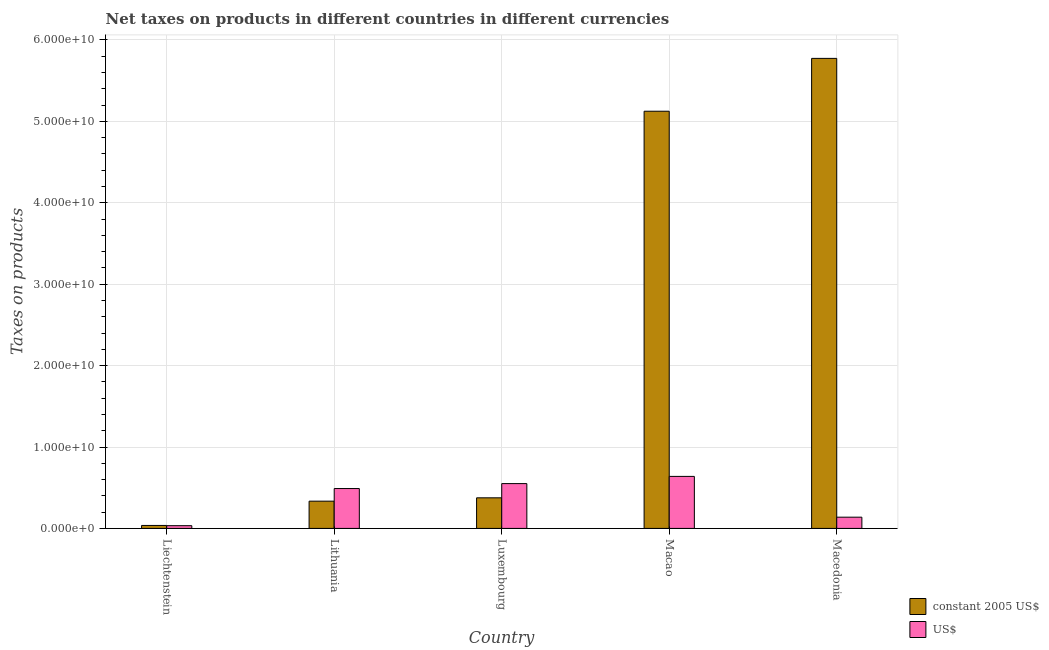Are the number of bars per tick equal to the number of legend labels?
Provide a short and direct response. Yes. Are the number of bars on each tick of the X-axis equal?
Make the answer very short. Yes. How many bars are there on the 5th tick from the left?
Your answer should be compact. 2. What is the label of the 1st group of bars from the left?
Keep it short and to the point. Liechtenstein. What is the net taxes in constant 2005 us$ in Liechtenstein?
Offer a terse response. 3.64e+08. Across all countries, what is the maximum net taxes in us$?
Ensure brevity in your answer.  6.39e+09. Across all countries, what is the minimum net taxes in us$?
Your answer should be very brief. 3.36e+08. In which country was the net taxes in constant 2005 us$ maximum?
Make the answer very short. Macedonia. In which country was the net taxes in us$ minimum?
Offer a terse response. Liechtenstein. What is the total net taxes in us$ in the graph?
Your answer should be very brief. 1.85e+1. What is the difference between the net taxes in constant 2005 us$ in Macao and that in Macedonia?
Give a very brief answer. -6.49e+09. What is the difference between the net taxes in us$ in Luxembourg and the net taxes in constant 2005 us$ in Liechtenstein?
Your answer should be compact. 5.14e+09. What is the average net taxes in constant 2005 us$ per country?
Make the answer very short. 2.33e+1. What is the difference between the net taxes in constant 2005 us$ and net taxes in us$ in Macao?
Give a very brief answer. 4.49e+1. In how many countries, is the net taxes in us$ greater than 24000000000 units?
Give a very brief answer. 0. What is the ratio of the net taxes in us$ in Macao to that in Macedonia?
Give a very brief answer. 4.63. Is the net taxes in us$ in Lithuania less than that in Luxembourg?
Your answer should be very brief. Yes. Is the difference between the net taxes in us$ in Liechtenstein and Macedonia greater than the difference between the net taxes in constant 2005 us$ in Liechtenstein and Macedonia?
Offer a terse response. Yes. What is the difference between the highest and the second highest net taxes in us$?
Your answer should be compact. 8.85e+08. What is the difference between the highest and the lowest net taxes in constant 2005 us$?
Your response must be concise. 5.74e+1. What does the 2nd bar from the left in Macao represents?
Your answer should be very brief. US$. What does the 1st bar from the right in Luxembourg represents?
Give a very brief answer. US$. How many countries are there in the graph?
Offer a very short reply. 5. Does the graph contain grids?
Your response must be concise. Yes. How are the legend labels stacked?
Give a very brief answer. Vertical. What is the title of the graph?
Your answer should be compact. Net taxes on products in different countries in different currencies. Does "Chemicals" appear as one of the legend labels in the graph?
Provide a succinct answer. No. What is the label or title of the X-axis?
Give a very brief answer. Country. What is the label or title of the Y-axis?
Your response must be concise. Taxes on products. What is the Taxes on products in constant 2005 US$ in Liechtenstein?
Make the answer very short. 3.64e+08. What is the Taxes on products in US$ in Liechtenstein?
Your answer should be very brief. 3.36e+08. What is the Taxes on products in constant 2005 US$ in Lithuania?
Give a very brief answer. 3.35e+09. What is the Taxes on products of US$ in Lithuania?
Give a very brief answer. 4.90e+09. What is the Taxes on products in constant 2005 US$ in Luxembourg?
Your response must be concise. 3.76e+09. What is the Taxes on products of US$ in Luxembourg?
Your answer should be very brief. 5.51e+09. What is the Taxes on products of constant 2005 US$ in Macao?
Your response must be concise. 5.12e+1. What is the Taxes on products in US$ in Macao?
Keep it short and to the point. 6.39e+09. What is the Taxes on products in constant 2005 US$ in Macedonia?
Your answer should be compact. 5.77e+1. What is the Taxes on products of US$ in Macedonia?
Give a very brief answer. 1.38e+09. Across all countries, what is the maximum Taxes on products of constant 2005 US$?
Your answer should be very brief. 5.77e+1. Across all countries, what is the maximum Taxes on products of US$?
Give a very brief answer. 6.39e+09. Across all countries, what is the minimum Taxes on products of constant 2005 US$?
Ensure brevity in your answer.  3.64e+08. Across all countries, what is the minimum Taxes on products of US$?
Provide a short and direct response. 3.36e+08. What is the total Taxes on products in constant 2005 US$ in the graph?
Your answer should be compact. 1.16e+11. What is the total Taxes on products in US$ in the graph?
Your response must be concise. 1.85e+1. What is the difference between the Taxes on products of constant 2005 US$ in Liechtenstein and that in Lithuania?
Make the answer very short. -2.98e+09. What is the difference between the Taxes on products in US$ in Liechtenstein and that in Lithuania?
Ensure brevity in your answer.  -4.56e+09. What is the difference between the Taxes on products in constant 2005 US$ in Liechtenstein and that in Luxembourg?
Ensure brevity in your answer.  -3.39e+09. What is the difference between the Taxes on products in US$ in Liechtenstein and that in Luxembourg?
Provide a succinct answer. -5.17e+09. What is the difference between the Taxes on products of constant 2005 US$ in Liechtenstein and that in Macao?
Your answer should be compact. -5.09e+1. What is the difference between the Taxes on products of US$ in Liechtenstein and that in Macao?
Give a very brief answer. -6.05e+09. What is the difference between the Taxes on products of constant 2005 US$ in Liechtenstein and that in Macedonia?
Your answer should be very brief. -5.74e+1. What is the difference between the Taxes on products in US$ in Liechtenstein and that in Macedonia?
Offer a very short reply. -1.04e+09. What is the difference between the Taxes on products in constant 2005 US$ in Lithuania and that in Luxembourg?
Keep it short and to the point. -4.11e+08. What is the difference between the Taxes on products of US$ in Lithuania and that in Luxembourg?
Your response must be concise. -6.07e+08. What is the difference between the Taxes on products of constant 2005 US$ in Lithuania and that in Macao?
Your response must be concise. -4.79e+1. What is the difference between the Taxes on products of US$ in Lithuania and that in Macao?
Keep it short and to the point. -1.49e+09. What is the difference between the Taxes on products of constant 2005 US$ in Lithuania and that in Macedonia?
Your response must be concise. -5.44e+1. What is the difference between the Taxes on products in US$ in Lithuania and that in Macedonia?
Offer a terse response. 3.52e+09. What is the difference between the Taxes on products in constant 2005 US$ in Luxembourg and that in Macao?
Ensure brevity in your answer.  -4.75e+1. What is the difference between the Taxes on products in US$ in Luxembourg and that in Macao?
Make the answer very short. -8.85e+08. What is the difference between the Taxes on products in constant 2005 US$ in Luxembourg and that in Macedonia?
Give a very brief answer. -5.40e+1. What is the difference between the Taxes on products in US$ in Luxembourg and that in Macedonia?
Provide a short and direct response. 4.13e+09. What is the difference between the Taxes on products of constant 2005 US$ in Macao and that in Macedonia?
Your answer should be compact. -6.49e+09. What is the difference between the Taxes on products in US$ in Macao and that in Macedonia?
Offer a very short reply. 5.01e+09. What is the difference between the Taxes on products of constant 2005 US$ in Liechtenstein and the Taxes on products of US$ in Lithuania?
Provide a succinct answer. -4.53e+09. What is the difference between the Taxes on products of constant 2005 US$ in Liechtenstein and the Taxes on products of US$ in Luxembourg?
Your answer should be very brief. -5.14e+09. What is the difference between the Taxes on products in constant 2005 US$ in Liechtenstein and the Taxes on products in US$ in Macao?
Provide a succinct answer. -6.03e+09. What is the difference between the Taxes on products of constant 2005 US$ in Liechtenstein and the Taxes on products of US$ in Macedonia?
Provide a short and direct response. -1.02e+09. What is the difference between the Taxes on products of constant 2005 US$ in Lithuania and the Taxes on products of US$ in Luxembourg?
Your answer should be very brief. -2.16e+09. What is the difference between the Taxes on products in constant 2005 US$ in Lithuania and the Taxes on products in US$ in Macao?
Provide a succinct answer. -3.04e+09. What is the difference between the Taxes on products of constant 2005 US$ in Lithuania and the Taxes on products of US$ in Macedonia?
Provide a succinct answer. 1.97e+09. What is the difference between the Taxes on products of constant 2005 US$ in Luxembourg and the Taxes on products of US$ in Macao?
Your answer should be compact. -2.63e+09. What is the difference between the Taxes on products in constant 2005 US$ in Luxembourg and the Taxes on products in US$ in Macedonia?
Offer a terse response. 2.38e+09. What is the difference between the Taxes on products in constant 2005 US$ in Macao and the Taxes on products in US$ in Macedonia?
Keep it short and to the point. 4.99e+1. What is the average Taxes on products of constant 2005 US$ per country?
Provide a short and direct response. 2.33e+1. What is the average Taxes on products in US$ per country?
Make the answer very short. 3.70e+09. What is the difference between the Taxes on products of constant 2005 US$ and Taxes on products of US$ in Liechtenstein?
Your answer should be compact. 2.79e+07. What is the difference between the Taxes on products of constant 2005 US$ and Taxes on products of US$ in Lithuania?
Provide a succinct answer. -1.55e+09. What is the difference between the Taxes on products of constant 2005 US$ and Taxes on products of US$ in Luxembourg?
Your response must be concise. -1.75e+09. What is the difference between the Taxes on products of constant 2005 US$ and Taxes on products of US$ in Macao?
Ensure brevity in your answer.  4.49e+1. What is the difference between the Taxes on products in constant 2005 US$ and Taxes on products in US$ in Macedonia?
Keep it short and to the point. 5.64e+1. What is the ratio of the Taxes on products of constant 2005 US$ in Liechtenstein to that in Lithuania?
Give a very brief answer. 0.11. What is the ratio of the Taxes on products of US$ in Liechtenstein to that in Lithuania?
Make the answer very short. 0.07. What is the ratio of the Taxes on products of constant 2005 US$ in Liechtenstein to that in Luxembourg?
Provide a short and direct response. 0.1. What is the ratio of the Taxes on products in US$ in Liechtenstein to that in Luxembourg?
Offer a terse response. 0.06. What is the ratio of the Taxes on products in constant 2005 US$ in Liechtenstein to that in Macao?
Your answer should be compact. 0.01. What is the ratio of the Taxes on products of US$ in Liechtenstein to that in Macao?
Your response must be concise. 0.05. What is the ratio of the Taxes on products of constant 2005 US$ in Liechtenstein to that in Macedonia?
Provide a succinct answer. 0.01. What is the ratio of the Taxes on products in US$ in Liechtenstein to that in Macedonia?
Provide a short and direct response. 0.24. What is the ratio of the Taxes on products of constant 2005 US$ in Lithuania to that in Luxembourg?
Keep it short and to the point. 0.89. What is the ratio of the Taxes on products of US$ in Lithuania to that in Luxembourg?
Give a very brief answer. 0.89. What is the ratio of the Taxes on products in constant 2005 US$ in Lithuania to that in Macao?
Offer a very short reply. 0.07. What is the ratio of the Taxes on products in US$ in Lithuania to that in Macao?
Offer a very short reply. 0.77. What is the ratio of the Taxes on products of constant 2005 US$ in Lithuania to that in Macedonia?
Give a very brief answer. 0.06. What is the ratio of the Taxes on products in US$ in Lithuania to that in Macedonia?
Offer a very short reply. 3.55. What is the ratio of the Taxes on products of constant 2005 US$ in Luxembourg to that in Macao?
Keep it short and to the point. 0.07. What is the ratio of the Taxes on products in US$ in Luxembourg to that in Macao?
Your answer should be compact. 0.86. What is the ratio of the Taxes on products of constant 2005 US$ in Luxembourg to that in Macedonia?
Provide a short and direct response. 0.07. What is the ratio of the Taxes on products of US$ in Luxembourg to that in Macedonia?
Give a very brief answer. 3.99. What is the ratio of the Taxes on products in constant 2005 US$ in Macao to that in Macedonia?
Keep it short and to the point. 0.89. What is the ratio of the Taxes on products in US$ in Macao to that in Macedonia?
Provide a short and direct response. 4.63. What is the difference between the highest and the second highest Taxes on products of constant 2005 US$?
Provide a succinct answer. 6.49e+09. What is the difference between the highest and the second highest Taxes on products of US$?
Your response must be concise. 8.85e+08. What is the difference between the highest and the lowest Taxes on products in constant 2005 US$?
Your answer should be very brief. 5.74e+1. What is the difference between the highest and the lowest Taxes on products in US$?
Your answer should be very brief. 6.05e+09. 